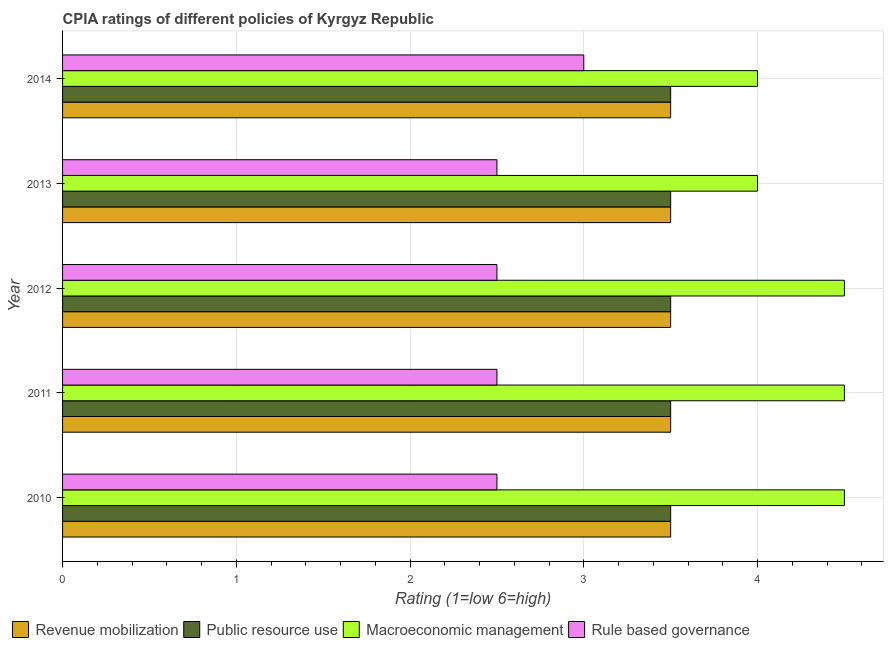How many different coloured bars are there?
Make the answer very short. 4. How many bars are there on the 2nd tick from the bottom?
Your answer should be compact. 4. What is the cpia rating of rule based governance in 2014?
Give a very brief answer. 3. Across all years, what is the maximum cpia rating of revenue mobilization?
Provide a succinct answer. 3.5. Across all years, what is the minimum cpia rating of rule based governance?
Give a very brief answer. 2.5. In which year was the cpia rating of revenue mobilization maximum?
Ensure brevity in your answer.  2010. In which year was the cpia rating of revenue mobilization minimum?
Keep it short and to the point. 2010. What is the difference between the cpia rating of public resource use in 2013 and that in 2014?
Offer a very short reply. 0. What is the difference between the cpia rating of public resource use in 2014 and the cpia rating of macroeconomic management in 2010?
Offer a terse response. -1. In the year 2010, what is the difference between the cpia rating of public resource use and cpia rating of revenue mobilization?
Offer a very short reply. 0. In how many years, is the cpia rating of public resource use greater than 1.8 ?
Give a very brief answer. 5. Is the cpia rating of revenue mobilization in 2010 less than that in 2013?
Your answer should be compact. No. What is the difference between the highest and the lowest cpia rating of rule based governance?
Give a very brief answer. 0.5. In how many years, is the cpia rating of revenue mobilization greater than the average cpia rating of revenue mobilization taken over all years?
Your answer should be very brief. 0. What does the 2nd bar from the top in 2010 represents?
Give a very brief answer. Macroeconomic management. What does the 2nd bar from the bottom in 2011 represents?
Keep it short and to the point. Public resource use. How many years are there in the graph?
Offer a very short reply. 5. What is the difference between two consecutive major ticks on the X-axis?
Provide a succinct answer. 1. Are the values on the major ticks of X-axis written in scientific E-notation?
Make the answer very short. No. Does the graph contain any zero values?
Ensure brevity in your answer.  No. How are the legend labels stacked?
Your answer should be very brief. Horizontal. What is the title of the graph?
Offer a terse response. CPIA ratings of different policies of Kyrgyz Republic. Does "Social equity" appear as one of the legend labels in the graph?
Offer a terse response. No. What is the label or title of the Y-axis?
Your answer should be compact. Year. What is the Rating (1=low 6=high) in Revenue mobilization in 2010?
Provide a short and direct response. 3.5. What is the Rating (1=low 6=high) in Public resource use in 2010?
Ensure brevity in your answer.  3.5. What is the Rating (1=low 6=high) of Macroeconomic management in 2010?
Your answer should be compact. 4.5. What is the Rating (1=low 6=high) of Revenue mobilization in 2011?
Your answer should be compact. 3.5. What is the Rating (1=low 6=high) in Public resource use in 2011?
Offer a terse response. 3.5. What is the Rating (1=low 6=high) in Revenue mobilization in 2012?
Give a very brief answer. 3.5. What is the Rating (1=low 6=high) in Public resource use in 2012?
Your answer should be compact. 3.5. What is the Rating (1=low 6=high) of Macroeconomic management in 2012?
Provide a short and direct response. 4.5. What is the Rating (1=low 6=high) of Revenue mobilization in 2013?
Your answer should be compact. 3.5. What is the Rating (1=low 6=high) of Macroeconomic management in 2013?
Make the answer very short. 4. What is the Rating (1=low 6=high) of Revenue mobilization in 2014?
Your response must be concise. 3.5. What is the Rating (1=low 6=high) in Public resource use in 2014?
Offer a terse response. 3.5. What is the Rating (1=low 6=high) in Macroeconomic management in 2014?
Your answer should be compact. 4. What is the Rating (1=low 6=high) of Rule based governance in 2014?
Offer a very short reply. 3. Across all years, what is the maximum Rating (1=low 6=high) of Revenue mobilization?
Offer a terse response. 3.5. Across all years, what is the maximum Rating (1=low 6=high) in Public resource use?
Ensure brevity in your answer.  3.5. Across all years, what is the maximum Rating (1=low 6=high) of Rule based governance?
Your answer should be very brief. 3. Across all years, what is the minimum Rating (1=low 6=high) of Public resource use?
Provide a short and direct response. 3.5. Across all years, what is the minimum Rating (1=low 6=high) of Macroeconomic management?
Provide a short and direct response. 4. What is the total Rating (1=low 6=high) in Public resource use in the graph?
Give a very brief answer. 17.5. What is the total Rating (1=low 6=high) in Rule based governance in the graph?
Provide a succinct answer. 13. What is the difference between the Rating (1=low 6=high) in Rule based governance in 2010 and that in 2011?
Make the answer very short. 0. What is the difference between the Rating (1=low 6=high) of Revenue mobilization in 2010 and that in 2012?
Provide a succinct answer. 0. What is the difference between the Rating (1=low 6=high) of Public resource use in 2010 and that in 2012?
Offer a very short reply. 0. What is the difference between the Rating (1=low 6=high) in Macroeconomic management in 2010 and that in 2012?
Make the answer very short. 0. What is the difference between the Rating (1=low 6=high) in Revenue mobilization in 2010 and that in 2013?
Your response must be concise. 0. What is the difference between the Rating (1=low 6=high) of Public resource use in 2010 and that in 2013?
Your answer should be very brief. 0. What is the difference between the Rating (1=low 6=high) in Revenue mobilization in 2010 and that in 2014?
Offer a very short reply. 0. What is the difference between the Rating (1=low 6=high) of Public resource use in 2010 and that in 2014?
Provide a short and direct response. 0. What is the difference between the Rating (1=low 6=high) of Macroeconomic management in 2010 and that in 2014?
Provide a short and direct response. 0.5. What is the difference between the Rating (1=low 6=high) of Public resource use in 2011 and that in 2012?
Provide a succinct answer. 0. What is the difference between the Rating (1=low 6=high) in Macroeconomic management in 2011 and that in 2012?
Provide a succinct answer. 0. What is the difference between the Rating (1=low 6=high) in Rule based governance in 2011 and that in 2012?
Offer a terse response. 0. What is the difference between the Rating (1=low 6=high) in Revenue mobilization in 2011 and that in 2013?
Your answer should be very brief. 0. What is the difference between the Rating (1=low 6=high) of Rule based governance in 2011 and that in 2013?
Your response must be concise. 0. What is the difference between the Rating (1=low 6=high) in Public resource use in 2011 and that in 2014?
Provide a short and direct response. 0. What is the difference between the Rating (1=low 6=high) in Rule based governance in 2011 and that in 2014?
Make the answer very short. -0.5. What is the difference between the Rating (1=low 6=high) of Revenue mobilization in 2012 and that in 2013?
Your answer should be compact. 0. What is the difference between the Rating (1=low 6=high) of Public resource use in 2012 and that in 2013?
Your answer should be compact. 0. What is the difference between the Rating (1=low 6=high) in Rule based governance in 2012 and that in 2013?
Give a very brief answer. 0. What is the difference between the Rating (1=low 6=high) of Revenue mobilization in 2012 and that in 2014?
Give a very brief answer. 0. What is the difference between the Rating (1=low 6=high) in Public resource use in 2012 and that in 2014?
Ensure brevity in your answer.  0. What is the difference between the Rating (1=low 6=high) of Macroeconomic management in 2012 and that in 2014?
Your response must be concise. 0.5. What is the difference between the Rating (1=low 6=high) of Revenue mobilization in 2013 and that in 2014?
Your answer should be compact. 0. What is the difference between the Rating (1=low 6=high) in Macroeconomic management in 2013 and that in 2014?
Your answer should be very brief. 0. What is the difference between the Rating (1=low 6=high) in Rule based governance in 2013 and that in 2014?
Ensure brevity in your answer.  -0.5. What is the difference between the Rating (1=low 6=high) of Revenue mobilization in 2010 and the Rating (1=low 6=high) of Public resource use in 2011?
Provide a succinct answer. 0. What is the difference between the Rating (1=low 6=high) of Revenue mobilization in 2010 and the Rating (1=low 6=high) of Macroeconomic management in 2011?
Give a very brief answer. -1. What is the difference between the Rating (1=low 6=high) in Revenue mobilization in 2010 and the Rating (1=low 6=high) in Rule based governance in 2011?
Ensure brevity in your answer.  1. What is the difference between the Rating (1=low 6=high) of Public resource use in 2010 and the Rating (1=low 6=high) of Macroeconomic management in 2011?
Your response must be concise. -1. What is the difference between the Rating (1=low 6=high) of Public resource use in 2010 and the Rating (1=low 6=high) of Rule based governance in 2011?
Your answer should be very brief. 1. What is the difference between the Rating (1=low 6=high) in Macroeconomic management in 2010 and the Rating (1=low 6=high) in Rule based governance in 2011?
Make the answer very short. 2. What is the difference between the Rating (1=low 6=high) in Revenue mobilization in 2010 and the Rating (1=low 6=high) in Rule based governance in 2012?
Offer a very short reply. 1. What is the difference between the Rating (1=low 6=high) of Public resource use in 2010 and the Rating (1=low 6=high) of Macroeconomic management in 2012?
Keep it short and to the point. -1. What is the difference between the Rating (1=low 6=high) of Revenue mobilization in 2010 and the Rating (1=low 6=high) of Public resource use in 2013?
Give a very brief answer. 0. What is the difference between the Rating (1=low 6=high) in Revenue mobilization in 2010 and the Rating (1=low 6=high) in Macroeconomic management in 2013?
Your answer should be compact. -0.5. What is the difference between the Rating (1=low 6=high) of Revenue mobilization in 2010 and the Rating (1=low 6=high) of Rule based governance in 2013?
Ensure brevity in your answer.  1. What is the difference between the Rating (1=low 6=high) of Public resource use in 2010 and the Rating (1=low 6=high) of Rule based governance in 2013?
Your response must be concise. 1. What is the difference between the Rating (1=low 6=high) in Macroeconomic management in 2010 and the Rating (1=low 6=high) in Rule based governance in 2013?
Ensure brevity in your answer.  2. What is the difference between the Rating (1=low 6=high) of Revenue mobilization in 2010 and the Rating (1=low 6=high) of Macroeconomic management in 2014?
Your response must be concise. -0.5. What is the difference between the Rating (1=low 6=high) of Public resource use in 2010 and the Rating (1=low 6=high) of Macroeconomic management in 2014?
Your answer should be very brief. -0.5. What is the difference between the Rating (1=low 6=high) of Public resource use in 2010 and the Rating (1=low 6=high) of Rule based governance in 2014?
Offer a terse response. 0.5. What is the difference between the Rating (1=low 6=high) in Macroeconomic management in 2010 and the Rating (1=low 6=high) in Rule based governance in 2014?
Offer a very short reply. 1.5. What is the difference between the Rating (1=low 6=high) in Revenue mobilization in 2011 and the Rating (1=low 6=high) in Macroeconomic management in 2012?
Your response must be concise. -1. What is the difference between the Rating (1=low 6=high) of Public resource use in 2011 and the Rating (1=low 6=high) of Rule based governance in 2012?
Ensure brevity in your answer.  1. What is the difference between the Rating (1=low 6=high) in Macroeconomic management in 2011 and the Rating (1=low 6=high) in Rule based governance in 2012?
Give a very brief answer. 2. What is the difference between the Rating (1=low 6=high) of Revenue mobilization in 2011 and the Rating (1=low 6=high) of Public resource use in 2013?
Ensure brevity in your answer.  0. What is the difference between the Rating (1=low 6=high) in Revenue mobilization in 2011 and the Rating (1=low 6=high) in Macroeconomic management in 2013?
Give a very brief answer. -0.5. What is the difference between the Rating (1=low 6=high) in Public resource use in 2011 and the Rating (1=low 6=high) in Macroeconomic management in 2013?
Provide a succinct answer. -0.5. What is the difference between the Rating (1=low 6=high) in Macroeconomic management in 2011 and the Rating (1=low 6=high) in Rule based governance in 2013?
Your response must be concise. 2. What is the difference between the Rating (1=low 6=high) in Revenue mobilization in 2011 and the Rating (1=low 6=high) in Public resource use in 2014?
Provide a short and direct response. 0. What is the difference between the Rating (1=low 6=high) in Revenue mobilization in 2011 and the Rating (1=low 6=high) in Macroeconomic management in 2014?
Keep it short and to the point. -0.5. What is the difference between the Rating (1=low 6=high) of Revenue mobilization in 2011 and the Rating (1=low 6=high) of Rule based governance in 2014?
Your answer should be very brief. 0.5. What is the difference between the Rating (1=low 6=high) in Revenue mobilization in 2012 and the Rating (1=low 6=high) in Public resource use in 2013?
Offer a terse response. 0. What is the difference between the Rating (1=low 6=high) of Revenue mobilization in 2012 and the Rating (1=low 6=high) of Macroeconomic management in 2013?
Your answer should be very brief. -0.5. What is the difference between the Rating (1=low 6=high) of Public resource use in 2012 and the Rating (1=low 6=high) of Macroeconomic management in 2013?
Your answer should be very brief. -0.5. What is the difference between the Rating (1=low 6=high) of Macroeconomic management in 2012 and the Rating (1=low 6=high) of Rule based governance in 2013?
Your answer should be compact. 2. What is the difference between the Rating (1=low 6=high) in Revenue mobilization in 2012 and the Rating (1=low 6=high) in Public resource use in 2014?
Provide a short and direct response. 0. What is the difference between the Rating (1=low 6=high) in Revenue mobilization in 2013 and the Rating (1=low 6=high) in Rule based governance in 2014?
Give a very brief answer. 0.5. What is the difference between the Rating (1=low 6=high) in Public resource use in 2013 and the Rating (1=low 6=high) in Macroeconomic management in 2014?
Offer a terse response. -0.5. What is the average Rating (1=low 6=high) of Public resource use per year?
Your answer should be compact. 3.5. What is the average Rating (1=low 6=high) in Rule based governance per year?
Your answer should be compact. 2.6. In the year 2010, what is the difference between the Rating (1=low 6=high) of Public resource use and Rating (1=low 6=high) of Rule based governance?
Provide a short and direct response. 1. In the year 2010, what is the difference between the Rating (1=low 6=high) of Macroeconomic management and Rating (1=low 6=high) of Rule based governance?
Provide a succinct answer. 2. In the year 2011, what is the difference between the Rating (1=low 6=high) in Revenue mobilization and Rating (1=low 6=high) in Macroeconomic management?
Your answer should be very brief. -1. In the year 2011, what is the difference between the Rating (1=low 6=high) in Revenue mobilization and Rating (1=low 6=high) in Rule based governance?
Offer a very short reply. 1. In the year 2011, what is the difference between the Rating (1=low 6=high) in Public resource use and Rating (1=low 6=high) in Macroeconomic management?
Your answer should be very brief. -1. In the year 2011, what is the difference between the Rating (1=low 6=high) in Public resource use and Rating (1=low 6=high) in Rule based governance?
Your answer should be compact. 1. In the year 2011, what is the difference between the Rating (1=low 6=high) of Macroeconomic management and Rating (1=low 6=high) of Rule based governance?
Your answer should be compact. 2. In the year 2012, what is the difference between the Rating (1=low 6=high) in Revenue mobilization and Rating (1=low 6=high) in Rule based governance?
Keep it short and to the point. 1. In the year 2012, what is the difference between the Rating (1=low 6=high) in Macroeconomic management and Rating (1=low 6=high) in Rule based governance?
Offer a very short reply. 2. In the year 2013, what is the difference between the Rating (1=low 6=high) in Revenue mobilization and Rating (1=low 6=high) in Public resource use?
Make the answer very short. 0. In the year 2013, what is the difference between the Rating (1=low 6=high) of Revenue mobilization and Rating (1=low 6=high) of Macroeconomic management?
Give a very brief answer. -0.5. In the year 2013, what is the difference between the Rating (1=low 6=high) in Public resource use and Rating (1=low 6=high) in Macroeconomic management?
Your answer should be very brief. -0.5. In the year 2013, what is the difference between the Rating (1=low 6=high) of Public resource use and Rating (1=low 6=high) of Rule based governance?
Provide a short and direct response. 1. In the year 2014, what is the difference between the Rating (1=low 6=high) in Revenue mobilization and Rating (1=low 6=high) in Macroeconomic management?
Provide a short and direct response. -0.5. In the year 2014, what is the difference between the Rating (1=low 6=high) of Revenue mobilization and Rating (1=low 6=high) of Rule based governance?
Provide a short and direct response. 0.5. In the year 2014, what is the difference between the Rating (1=low 6=high) of Public resource use and Rating (1=low 6=high) of Macroeconomic management?
Keep it short and to the point. -0.5. In the year 2014, what is the difference between the Rating (1=low 6=high) of Public resource use and Rating (1=low 6=high) of Rule based governance?
Provide a succinct answer. 0.5. In the year 2014, what is the difference between the Rating (1=low 6=high) of Macroeconomic management and Rating (1=low 6=high) of Rule based governance?
Ensure brevity in your answer.  1. What is the ratio of the Rating (1=low 6=high) of Revenue mobilization in 2010 to that in 2011?
Provide a short and direct response. 1. What is the ratio of the Rating (1=low 6=high) in Macroeconomic management in 2010 to that in 2011?
Your answer should be compact. 1. What is the ratio of the Rating (1=low 6=high) of Rule based governance in 2010 to that in 2011?
Your response must be concise. 1. What is the ratio of the Rating (1=low 6=high) in Macroeconomic management in 2010 to that in 2012?
Keep it short and to the point. 1. What is the ratio of the Rating (1=low 6=high) in Public resource use in 2010 to that in 2013?
Offer a very short reply. 1. What is the ratio of the Rating (1=low 6=high) of Macroeconomic management in 2010 to that in 2013?
Provide a short and direct response. 1.12. What is the ratio of the Rating (1=low 6=high) in Public resource use in 2010 to that in 2014?
Make the answer very short. 1. What is the ratio of the Rating (1=low 6=high) of Macroeconomic management in 2010 to that in 2014?
Provide a short and direct response. 1.12. What is the ratio of the Rating (1=low 6=high) in Rule based governance in 2010 to that in 2014?
Keep it short and to the point. 0.83. What is the ratio of the Rating (1=low 6=high) in Macroeconomic management in 2011 to that in 2013?
Provide a succinct answer. 1.12. What is the ratio of the Rating (1=low 6=high) of Rule based governance in 2011 to that in 2013?
Your answer should be compact. 1. What is the ratio of the Rating (1=low 6=high) of Revenue mobilization in 2011 to that in 2014?
Give a very brief answer. 1. What is the ratio of the Rating (1=low 6=high) of Public resource use in 2011 to that in 2014?
Ensure brevity in your answer.  1. What is the ratio of the Rating (1=low 6=high) of Macroeconomic management in 2011 to that in 2014?
Provide a short and direct response. 1.12. What is the ratio of the Rating (1=low 6=high) of Revenue mobilization in 2012 to that in 2013?
Keep it short and to the point. 1. What is the ratio of the Rating (1=low 6=high) of Macroeconomic management in 2012 to that in 2013?
Your response must be concise. 1.12. What is the ratio of the Rating (1=low 6=high) of Revenue mobilization in 2012 to that in 2014?
Ensure brevity in your answer.  1. What is the ratio of the Rating (1=low 6=high) in Public resource use in 2012 to that in 2014?
Your response must be concise. 1. What is the ratio of the Rating (1=low 6=high) in Macroeconomic management in 2012 to that in 2014?
Provide a succinct answer. 1.12. What is the ratio of the Rating (1=low 6=high) of Revenue mobilization in 2013 to that in 2014?
Your answer should be very brief. 1. What is the ratio of the Rating (1=low 6=high) of Public resource use in 2013 to that in 2014?
Your answer should be very brief. 1. What is the ratio of the Rating (1=low 6=high) of Macroeconomic management in 2013 to that in 2014?
Offer a very short reply. 1. What is the difference between the highest and the second highest Rating (1=low 6=high) of Public resource use?
Your answer should be compact. 0. What is the difference between the highest and the second highest Rating (1=low 6=high) of Macroeconomic management?
Your response must be concise. 0. What is the difference between the highest and the lowest Rating (1=low 6=high) of Revenue mobilization?
Give a very brief answer. 0. What is the difference between the highest and the lowest Rating (1=low 6=high) in Public resource use?
Make the answer very short. 0. What is the difference between the highest and the lowest Rating (1=low 6=high) of Macroeconomic management?
Ensure brevity in your answer.  0.5. What is the difference between the highest and the lowest Rating (1=low 6=high) in Rule based governance?
Give a very brief answer. 0.5. 